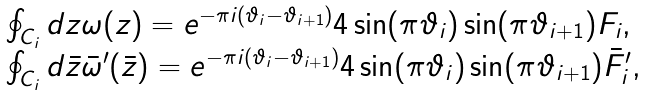<formula> <loc_0><loc_0><loc_500><loc_500>\begin{array} { l } \oint _ { C _ { i } } d z \omega ( z ) = e ^ { - \pi i ( \vartheta _ { i } - \vartheta _ { i + 1 } ) } 4 \sin ( \pi \vartheta _ { i } ) \sin ( \pi \vartheta _ { i + 1 } ) F _ { i } , \\ \oint _ { C _ { i } } d \bar { z } \bar { \omega } ^ { \prime } ( \bar { z } ) = e ^ { - \pi i ( \vartheta _ { i } - \vartheta _ { i + 1 } ) } 4 \sin ( \pi \vartheta _ { i } ) \sin ( \pi \vartheta _ { i + 1 } ) \bar { F } ^ { \prime } _ { i } , \end{array}</formula> 